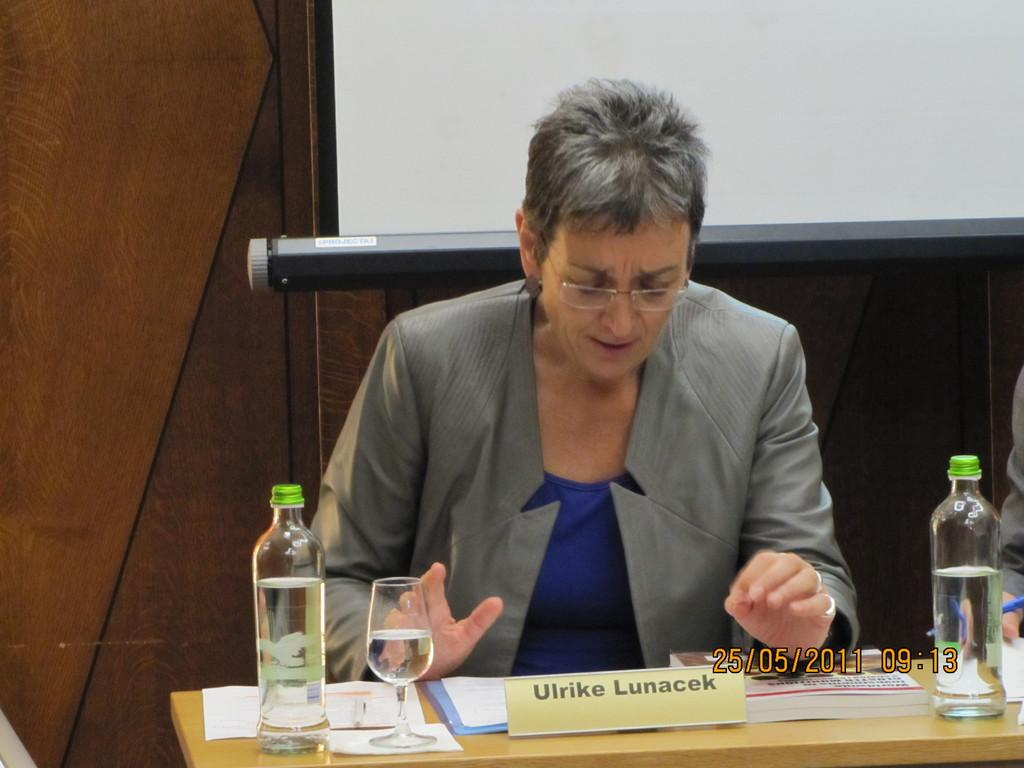Who is present in the image? There is a lady in the image. What is the lady wearing that is visible in the image? The lady is wearing glasses (specs) in the image. What can be seen on the table in the image? There is a nameplate, a glass bottle, and papers on the table in the image. What is the background of the image made of? There is a wooden wall in the background of the image. What type of food is the boy eating in the image? There is no boy present in the image, and therefore no such activity can be observed. 